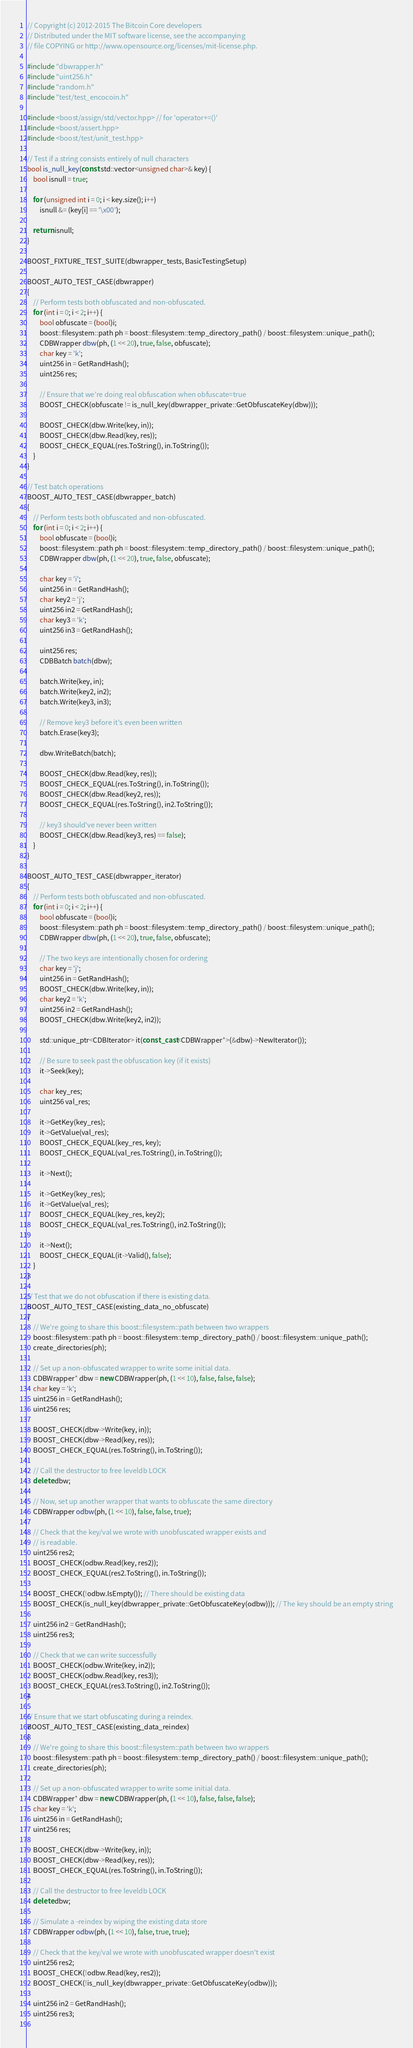<code> <loc_0><loc_0><loc_500><loc_500><_C++_>// Copyright (c) 2012-2015 The Bitcoin Core developers
// Distributed under the MIT software license, see the accompanying
// file COPYING or http://www.opensource.org/licenses/mit-license.php.

#include "dbwrapper.h"
#include "uint256.h"
#include "random.h"
#include "test/test_encocoin.h"

#include <boost/assign/std/vector.hpp> // for 'operator+=()'
#include <boost/assert.hpp>
#include <boost/test/unit_test.hpp>

// Test if a string consists entirely of null characters
bool is_null_key(const std::vector<unsigned char>& key) {
    bool isnull = true;

    for (unsigned int i = 0; i < key.size(); i++)
        isnull &= (key[i] == '\x00');

    return isnull;
}
 
BOOST_FIXTURE_TEST_SUITE(dbwrapper_tests, BasicTestingSetup)
                       
BOOST_AUTO_TEST_CASE(dbwrapper)
{
    // Perform tests both obfuscated and non-obfuscated.
    for (int i = 0; i < 2; i++) {
        bool obfuscate = (bool)i;
        boost::filesystem::path ph = boost::filesystem::temp_directory_path() / boost::filesystem::unique_path();
        CDBWrapper dbw(ph, (1 << 20), true, false, obfuscate);
        char key = 'k';
        uint256 in = GetRandHash();
        uint256 res;

        // Ensure that we're doing real obfuscation when obfuscate=true
        BOOST_CHECK(obfuscate != is_null_key(dbwrapper_private::GetObfuscateKey(dbw)));

        BOOST_CHECK(dbw.Write(key, in));
        BOOST_CHECK(dbw.Read(key, res));
        BOOST_CHECK_EQUAL(res.ToString(), in.ToString());
    }
}

// Test batch operations
BOOST_AUTO_TEST_CASE(dbwrapper_batch)
{
    // Perform tests both obfuscated and non-obfuscated.
    for (int i = 0; i < 2; i++) {
        bool obfuscate = (bool)i;
        boost::filesystem::path ph = boost::filesystem::temp_directory_path() / boost::filesystem::unique_path();
        CDBWrapper dbw(ph, (1 << 20), true, false, obfuscate);

        char key = 'i';
        uint256 in = GetRandHash();
        char key2 = 'j';
        uint256 in2 = GetRandHash();
        char key3 = 'k';
        uint256 in3 = GetRandHash();

        uint256 res;
        CDBBatch batch(dbw);

        batch.Write(key, in);
        batch.Write(key2, in2);
        batch.Write(key3, in3);

        // Remove key3 before it's even been written
        batch.Erase(key3);

        dbw.WriteBatch(batch);

        BOOST_CHECK(dbw.Read(key, res));
        BOOST_CHECK_EQUAL(res.ToString(), in.ToString());
        BOOST_CHECK(dbw.Read(key2, res));
        BOOST_CHECK_EQUAL(res.ToString(), in2.ToString());

        // key3 should've never been written
        BOOST_CHECK(dbw.Read(key3, res) == false);
    }
}

BOOST_AUTO_TEST_CASE(dbwrapper_iterator)
{
    // Perform tests both obfuscated and non-obfuscated.
    for (int i = 0; i < 2; i++) {
        bool obfuscate = (bool)i;
        boost::filesystem::path ph = boost::filesystem::temp_directory_path() / boost::filesystem::unique_path();
        CDBWrapper dbw(ph, (1 << 20), true, false, obfuscate);

        // The two keys are intentionally chosen for ordering
        char key = 'j';
        uint256 in = GetRandHash();
        BOOST_CHECK(dbw.Write(key, in));
        char key2 = 'k';
        uint256 in2 = GetRandHash();
        BOOST_CHECK(dbw.Write(key2, in2));

        std::unique_ptr<CDBIterator> it(const_cast<CDBWrapper*>(&dbw)->NewIterator());

        // Be sure to seek past the obfuscation key (if it exists)
        it->Seek(key);

        char key_res;
        uint256 val_res;

        it->GetKey(key_res);
        it->GetValue(val_res);
        BOOST_CHECK_EQUAL(key_res, key);
        BOOST_CHECK_EQUAL(val_res.ToString(), in.ToString());

        it->Next();

        it->GetKey(key_res);
        it->GetValue(val_res);
        BOOST_CHECK_EQUAL(key_res, key2);
        BOOST_CHECK_EQUAL(val_res.ToString(), in2.ToString());

        it->Next();
        BOOST_CHECK_EQUAL(it->Valid(), false);
    }
}

// Test that we do not obfuscation if there is existing data.
BOOST_AUTO_TEST_CASE(existing_data_no_obfuscate)
{
    // We're going to share this boost::filesystem::path between two wrappers
    boost::filesystem::path ph = boost::filesystem::temp_directory_path() / boost::filesystem::unique_path();
    create_directories(ph);

    // Set up a non-obfuscated wrapper to write some initial data.
    CDBWrapper* dbw = new CDBWrapper(ph, (1 << 10), false, false, false);
    char key = 'k';
    uint256 in = GetRandHash();
    uint256 res;

    BOOST_CHECK(dbw->Write(key, in));
    BOOST_CHECK(dbw->Read(key, res));
    BOOST_CHECK_EQUAL(res.ToString(), in.ToString());

    // Call the destructor to free leveldb LOCK
    delete dbw;

    // Now, set up another wrapper that wants to obfuscate the same directory
    CDBWrapper odbw(ph, (1 << 10), false, false, true);

    // Check that the key/val we wrote with unobfuscated wrapper exists and 
    // is readable.
    uint256 res2;
    BOOST_CHECK(odbw.Read(key, res2));
    BOOST_CHECK_EQUAL(res2.ToString(), in.ToString());

    BOOST_CHECK(!odbw.IsEmpty()); // There should be existing data
    BOOST_CHECK(is_null_key(dbwrapper_private::GetObfuscateKey(odbw))); // The key should be an empty string

    uint256 in2 = GetRandHash();
    uint256 res3;
 
    // Check that we can write successfully
    BOOST_CHECK(odbw.Write(key, in2));
    BOOST_CHECK(odbw.Read(key, res3));
    BOOST_CHECK_EQUAL(res3.ToString(), in2.ToString());
}
                        
// Ensure that we start obfuscating during a reindex.
BOOST_AUTO_TEST_CASE(existing_data_reindex)
{
    // We're going to share this boost::filesystem::path between two wrappers
    boost::filesystem::path ph = boost::filesystem::temp_directory_path() / boost::filesystem::unique_path();
    create_directories(ph);

    // Set up a non-obfuscated wrapper to write some initial data.
    CDBWrapper* dbw = new CDBWrapper(ph, (1 << 10), false, false, false);
    char key = 'k';
    uint256 in = GetRandHash();
    uint256 res;

    BOOST_CHECK(dbw->Write(key, in));
    BOOST_CHECK(dbw->Read(key, res));
    BOOST_CHECK_EQUAL(res.ToString(), in.ToString());

    // Call the destructor to free leveldb LOCK
    delete dbw;

    // Simulate a -reindex by wiping the existing data store
    CDBWrapper odbw(ph, (1 << 10), false, true, true);

    // Check that the key/val we wrote with unobfuscated wrapper doesn't exist
    uint256 res2;
    BOOST_CHECK(!odbw.Read(key, res2));
    BOOST_CHECK(!is_null_key(dbwrapper_private::GetObfuscateKey(odbw)));

    uint256 in2 = GetRandHash();
    uint256 res3;
 </code> 